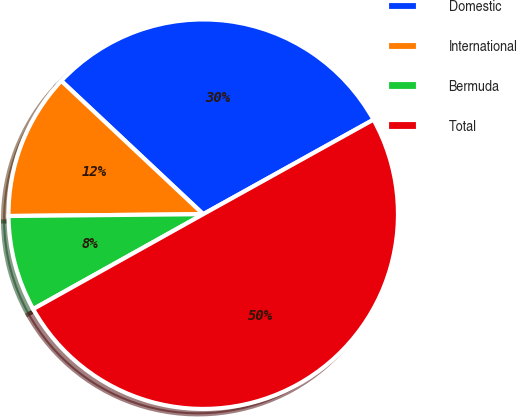Convert chart. <chart><loc_0><loc_0><loc_500><loc_500><pie_chart><fcel>Domestic<fcel>International<fcel>Bermuda<fcel>Total<nl><fcel>29.93%<fcel>12.15%<fcel>7.95%<fcel>49.96%<nl></chart> 